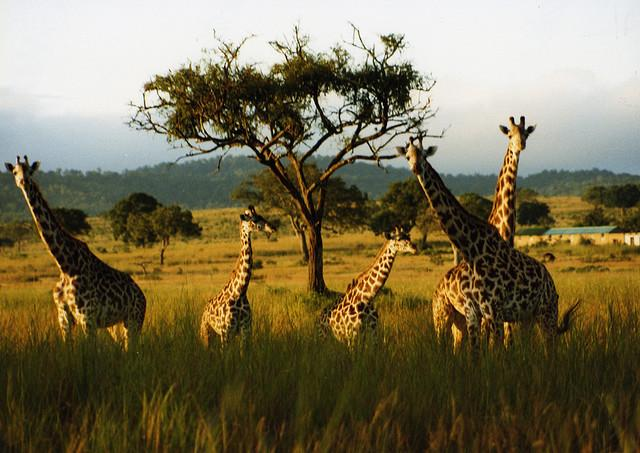How heavy is a newborn giraffe calf in general?

Choices:
A) 100 kg
B) 70 kg
C) 80 kg
D) 60 kg 100 kg 